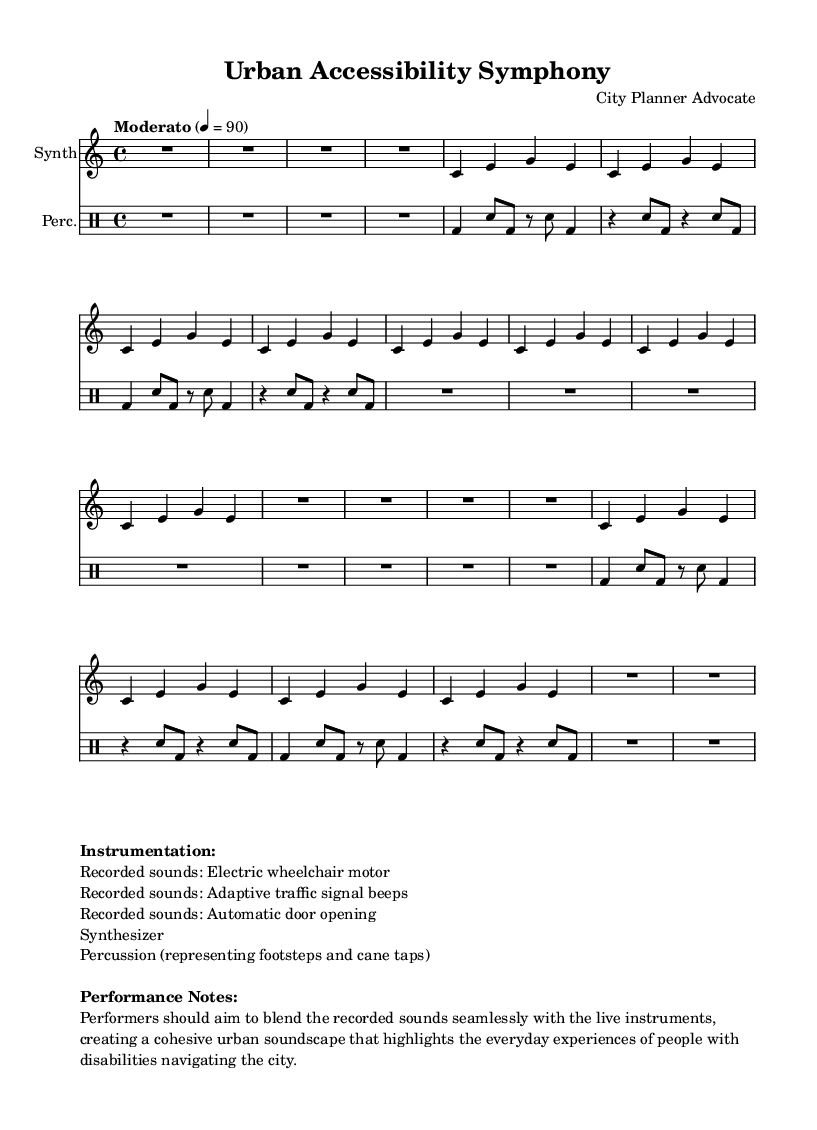What is the key signature of this music? The key signature indicated in the score is C major, signifying no sharps or flats.
Answer: C major What is the time signature of this music? The time signature shown is 4/4, indicating there are four beats in each measure.
Answer: 4/4 What is the tempo marking for this piece? The tempo marking is "Moderato," which suggests a moderate speed, indicated by the note value of 4 = 90.
Answer: Moderato How many recorded sounds are listed in the instrumentation? The score lists three recorded sounds: electric wheelchair motor, adaptive traffic signal beeps, and automatic door opening, alongside the synth and percussion.
Answer: Five What types of rhythmic instruments are included in this piece? The percussion includes sounds that represent footsteps and cane taps, indicating they are part of the rhythmic texture.
Answer: Footsteps and cane taps Why should performers blend recorded and live sounds? The performance notes indicate that blending is essential for creating a cohesive urban soundscape that reflects the experiences of people with disabilities, thus enhancing the piece's thematic expression.
Answer: To create a cohesive urban soundscape What does the term 'Musique concrète' signify in this context? It refers to a style of music that uses recorded sounds as the primary material, emphasizing the everyday experiences and environmental sounds much like those used here.
Answer: Recorded sounds as primary material 